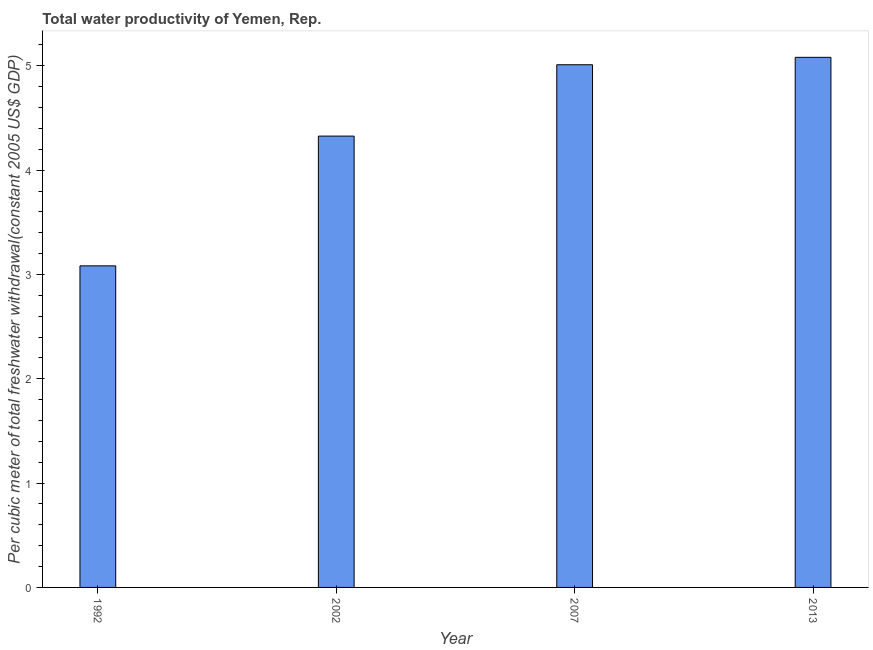What is the title of the graph?
Provide a short and direct response. Total water productivity of Yemen, Rep. What is the label or title of the Y-axis?
Offer a terse response. Per cubic meter of total freshwater withdrawal(constant 2005 US$ GDP). What is the total water productivity in 2007?
Make the answer very short. 5.01. Across all years, what is the maximum total water productivity?
Provide a short and direct response. 5.08. Across all years, what is the minimum total water productivity?
Your response must be concise. 3.08. In which year was the total water productivity maximum?
Offer a terse response. 2013. What is the sum of the total water productivity?
Keep it short and to the point. 17.5. What is the difference between the total water productivity in 1992 and 2002?
Make the answer very short. -1.24. What is the average total water productivity per year?
Your answer should be compact. 4.38. What is the median total water productivity?
Provide a short and direct response. 4.67. In how many years, is the total water productivity greater than 1 US$?
Ensure brevity in your answer.  4. Do a majority of the years between 1992 and 2013 (inclusive) have total water productivity greater than 2.8 US$?
Your response must be concise. Yes. What is the ratio of the total water productivity in 1992 to that in 2007?
Keep it short and to the point. 0.61. Is the total water productivity in 1992 less than that in 2013?
Make the answer very short. Yes. Is the difference between the total water productivity in 2002 and 2013 greater than the difference between any two years?
Your answer should be very brief. No. What is the difference between the highest and the second highest total water productivity?
Make the answer very short. 0.07. Is the sum of the total water productivity in 2007 and 2013 greater than the maximum total water productivity across all years?
Your response must be concise. Yes. What is the difference between the highest and the lowest total water productivity?
Provide a succinct answer. 2. How many years are there in the graph?
Your answer should be very brief. 4. What is the difference between two consecutive major ticks on the Y-axis?
Make the answer very short. 1. What is the Per cubic meter of total freshwater withdrawal(constant 2005 US$ GDP) of 1992?
Keep it short and to the point. 3.08. What is the Per cubic meter of total freshwater withdrawal(constant 2005 US$ GDP) in 2002?
Your answer should be very brief. 4.33. What is the Per cubic meter of total freshwater withdrawal(constant 2005 US$ GDP) in 2007?
Make the answer very short. 5.01. What is the Per cubic meter of total freshwater withdrawal(constant 2005 US$ GDP) in 2013?
Provide a succinct answer. 5.08. What is the difference between the Per cubic meter of total freshwater withdrawal(constant 2005 US$ GDP) in 1992 and 2002?
Your answer should be compact. -1.24. What is the difference between the Per cubic meter of total freshwater withdrawal(constant 2005 US$ GDP) in 1992 and 2007?
Provide a succinct answer. -1.93. What is the difference between the Per cubic meter of total freshwater withdrawal(constant 2005 US$ GDP) in 1992 and 2013?
Offer a terse response. -2. What is the difference between the Per cubic meter of total freshwater withdrawal(constant 2005 US$ GDP) in 2002 and 2007?
Provide a succinct answer. -0.68. What is the difference between the Per cubic meter of total freshwater withdrawal(constant 2005 US$ GDP) in 2002 and 2013?
Provide a short and direct response. -0.76. What is the difference between the Per cubic meter of total freshwater withdrawal(constant 2005 US$ GDP) in 2007 and 2013?
Ensure brevity in your answer.  -0.07. What is the ratio of the Per cubic meter of total freshwater withdrawal(constant 2005 US$ GDP) in 1992 to that in 2002?
Ensure brevity in your answer.  0.71. What is the ratio of the Per cubic meter of total freshwater withdrawal(constant 2005 US$ GDP) in 1992 to that in 2007?
Your answer should be very brief. 0.61. What is the ratio of the Per cubic meter of total freshwater withdrawal(constant 2005 US$ GDP) in 1992 to that in 2013?
Your answer should be compact. 0.61. What is the ratio of the Per cubic meter of total freshwater withdrawal(constant 2005 US$ GDP) in 2002 to that in 2007?
Offer a very short reply. 0.86. What is the ratio of the Per cubic meter of total freshwater withdrawal(constant 2005 US$ GDP) in 2002 to that in 2013?
Your answer should be compact. 0.85. 